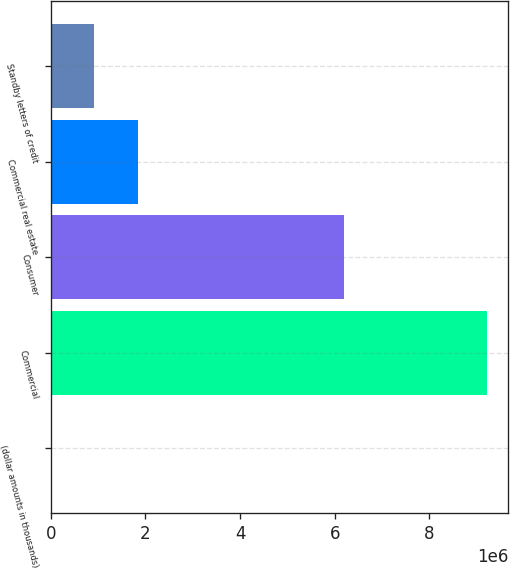Convert chart to OTSL. <chart><loc_0><loc_0><loc_500><loc_500><bar_chart><fcel>(dollar amounts in thousands)<fcel>Commercial<fcel>Consumer<fcel>Commercial real estate<fcel>Standby letters of credit<nl><fcel>2012<fcel>9.20909e+06<fcel>6.18945e+06<fcel>1.84343e+06<fcel>922720<nl></chart> 